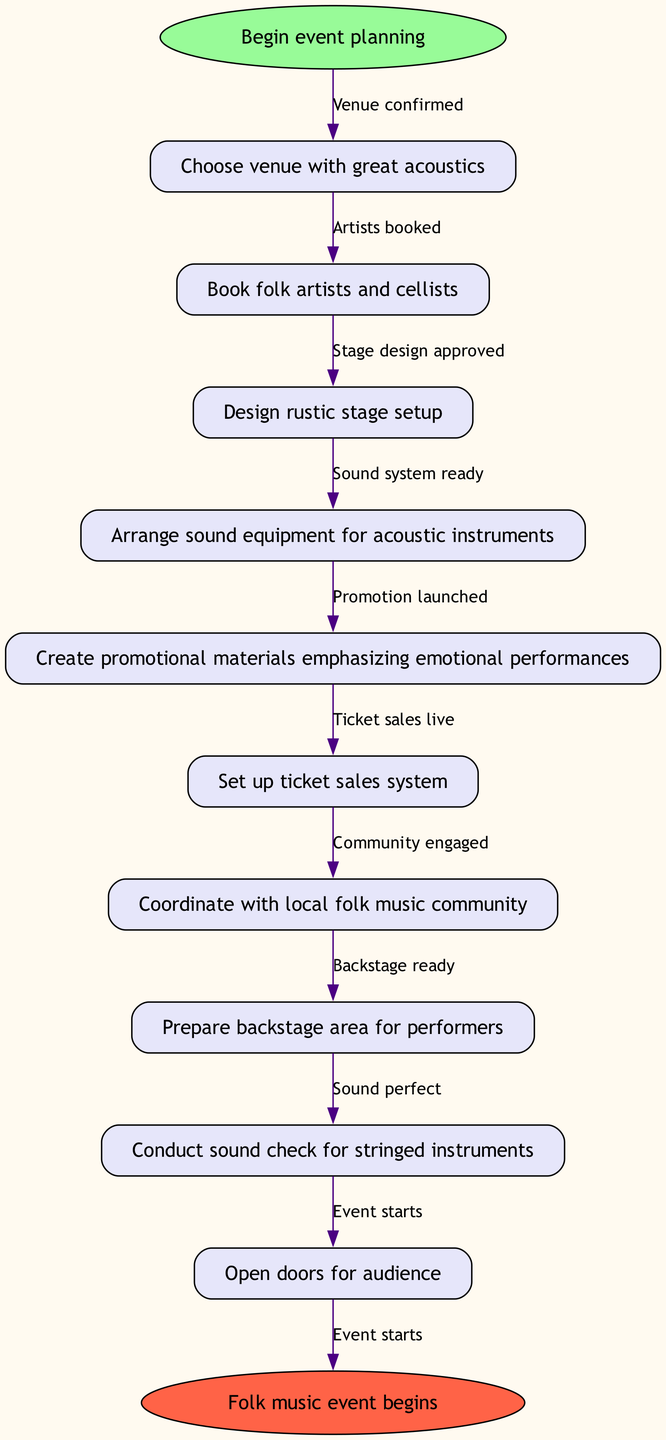What is the starting point of the workflow? The starting point is clearly labeled in the diagram as "Begin event planning," which is represented at the top of the flowchart as the first oval node.
Answer: Begin event planning How many nodes are there in the diagram? The diagram features a total of ten nodes, which include one start node, eight intermediate steps, and one end node. Counting them gives us a total of ten nodes.
Answer: 10 What is the last step before the event begins? The last step before reaching the conclusion of the workflow is "Open doors for audience," which directly precedes the outcome of the entire flowchart.
Answer: Open doors for audience What is the relationship between booking artists and arranging sound equipment? The flowchart indicates a direct sequential relationship where "Book folk artists and cellists" is the second step, followed by "Arrange sound equipment for acoustic instruments," showing that sound equipment arrangement follows the artist booking process.
Answer: Sequential Which node indicates the launch of promotions? The node that indicates the launch of promotions is "Promotion launched," which is placed toward the middle of the flowchart after several other planning steps.
Answer: Promotion launched How does the workflow conclude? The workflow concludes with the node "Folk music event begins," which represents the final outcome of the entire planning and execution process, showing when the event officially starts.
Answer: Folk music event begins What is the penultimate node before the event starts? The penultimate node is "Sound perfect," which comes just before the final step of the event commencement, providing an indication that the setup is completed and the event is ready to begin.
Answer: Sound perfect How is the venue confirmed in relation to the first node? The confirmation of the venue directly follows from the first node "Choose venue with great acoustics" and is represented by the edge labeled "Venue confirmed," indicating that the venue selection process leads to its confirmation.
Answer: Venue confirmed 